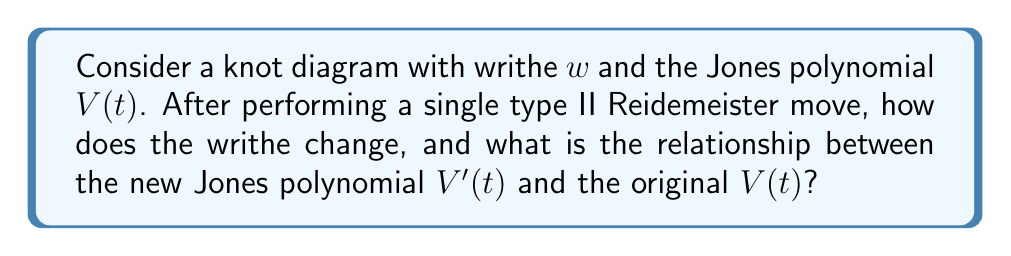What is the answer to this math problem? Let's approach this step-by-step:

1) Writhe change:
   - A type II Reidemeister move either adds or removes two crossings of opposite sign.
   - If it adds two crossings, one is positive and one is negative.
   - If it removes two crossings, again one is positive and one is negative.
   - Therefore, the net change in writhe is always zero for a type II move.

2) Jones polynomial change:
   - The Jones polynomial is invariant under Reidemeister moves, meaning it doesn't change.
   - Mathematically, this means $V'(t) = V(t)$.

3) Why this is relevant to a fan page administrator:
   - Understanding knot invariants like writhe and the Jones polynomial can help in analyzing the complexity and uniqueness of knots.
   - This could be applied to create engaging content about the intricacies of knot theory, potentially relating it to the veteran's career achievements or interests.

4) Verification:
   - We can verify this by considering the skein relation for the Jones polynomial:
     $$t^{-1}V(L_+) - tV(L_-) = (t^{1/2} - t^{-1/2})V(L_0)$$
   - For a type II move, we're essentially adding or removing a "bubble" in the knot diagram.
   - This operation doesn't affect the overall polynomial due to the cancellation in the skein relation.
Answer: Writhe change: 0; $V'(t) = V(t)$ 